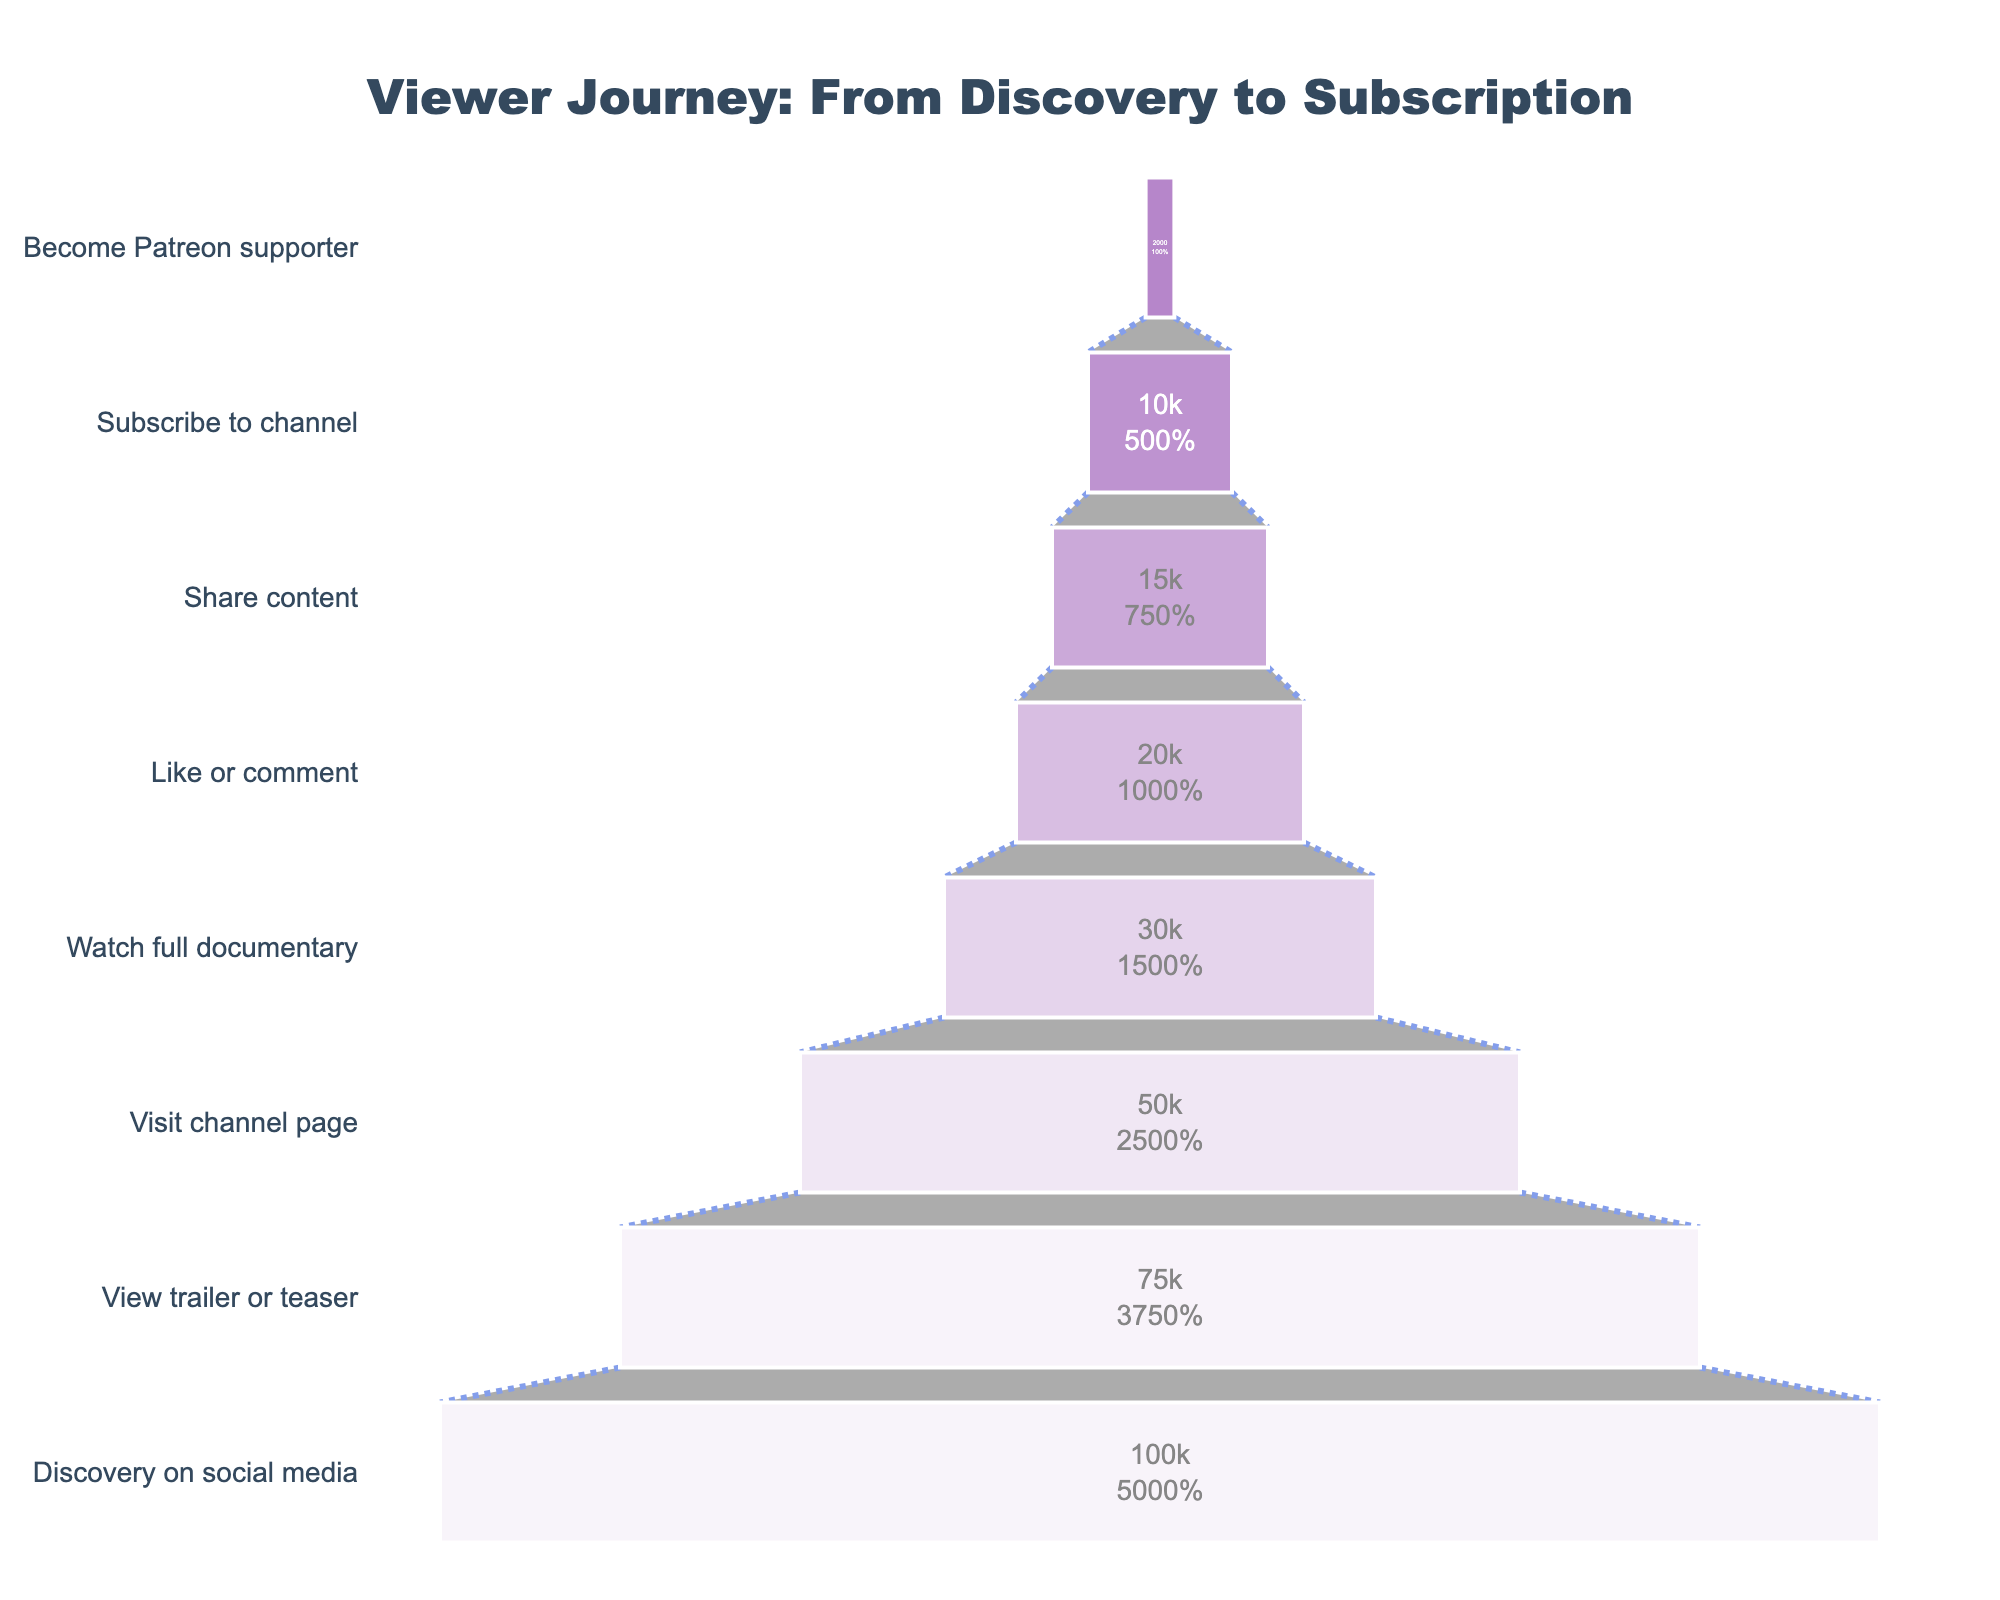What is the title of the funnel chart? The chart title is displayed prominently at the top center of the figure. It reads "Viewer Journey: From Discovery to Subscription".
Answer: Viewer Journey: From Discovery to Subscription How many people discovered the documentary content on social media? The number of users at the "Discovery on social media" stage is indicated inside the funnel. It shows 100,000 users.
Answer: 100,000 What percentage of users subscribed to the channel after visiting the channel page? First, find the number of users who visited the channel page (50,000) and then find the users who subscribed to the channel (10,000). Calculate the percentage as (10,000 / 50,000) * 100.
Answer: 20% What is the difference in the number of users between those who shared the content and those who became Patreon supporters? The number of users who shared the content is 15,000 and those who became Patreon supporters are 2,000. Subtract the latter from the former (15,000 - 2,000).
Answer: 13,000 Which stage has the highest drop-off rate? To determine the drop-off rate, compare the number of users between consecutive stages. The largest drop-off occurs between "View trailer or teaser" (75,000) and "Visit channel page" (50,000), with a drop of 25,000 users.
Answer: View trailer or teaser to Visit channel page How many users liked or commented on the documentary content and what percentage of the initial discovery stage does this represent? The number of users who liked or commented is 20,000. The initial stage (discovery) had 100,000 users. The percentage is calculated as (20,000 / 100,000) * 100.
Answer: 20% What is the ratio of users who visited the channel page to those who watched the full documentary? The number of users who visited the channel page is 50,000 and who watched the full documentary is 30,000. The ratio is 50,000 / 30,000.
Answer: 5:3 How many users completed all stages from discovery to Patreon support? The number of users at the final stage, "Become Patreon supporter," represents those who completed all stages. This number is 2,000.
Answer: 2,000 